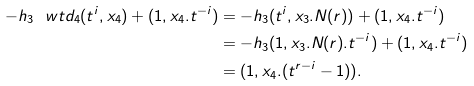Convert formula to latex. <formula><loc_0><loc_0><loc_500><loc_500>- h _ { 3 } \ w t d _ { 4 } ( t ^ { i } , x _ { 4 } ) + ( 1 , x _ { 4 } . t ^ { - i } ) & = - h _ { 3 } ( t ^ { i } , x _ { 3 } . N ( r ) ) + ( 1 , x _ { 4 } . t ^ { - i } ) \\ & = - h _ { 3 } ( 1 , x _ { 3 } . N ( r ) . t ^ { - i } ) + ( 1 , x _ { 4 } . t ^ { - i } ) \\ & = ( 1 , x _ { 4 } . ( t ^ { r - i } - 1 ) ) .</formula> 